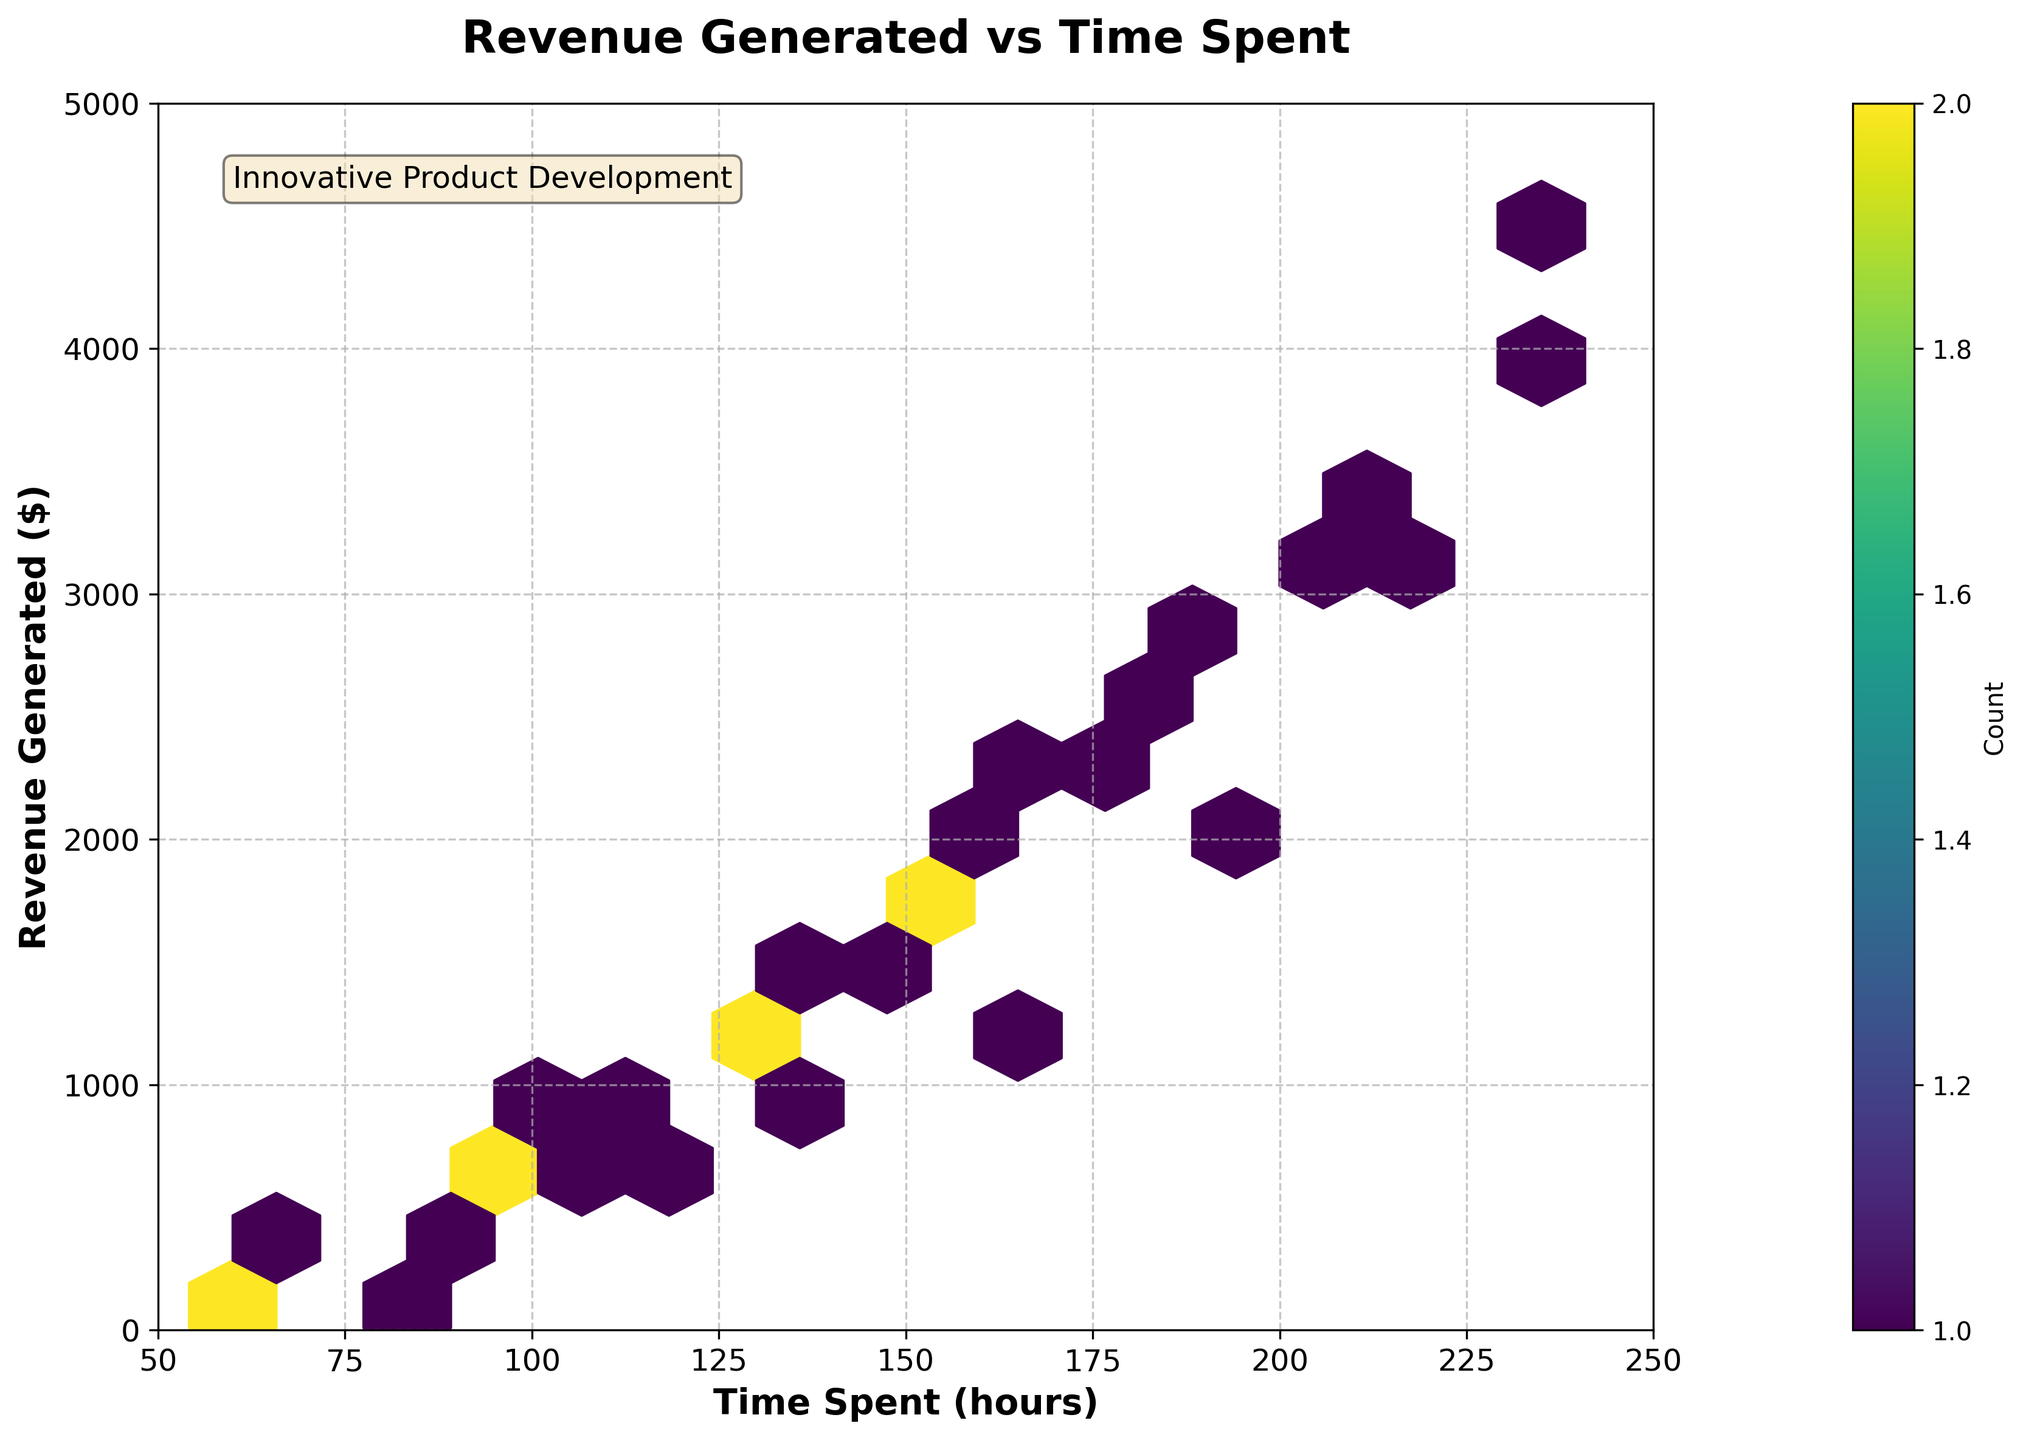What is the title of the figure? The title of the figure is usually written at the top center of the figure. In this case, it is 'Revenue Generated vs Time Spent'.
Answer: 'Revenue Generated vs Time Spent' What ranges are covered by the x-axis and y-axis? The x-axis range is from 50 to 250, and the y-axis range is from 0 to 5000. These ranges are indicated by the limits set on the x and y axes respectively.
Answer: x-axis: 50-250, y-axis: 0-5000 How many data points are there with 'Time Spent (hours)' approximately at 100 and 'Revenue Generated ($)' around 800? The hexbin plot shows hexagons colored based on the count of data points within that bin. By looking at the color intensity of the hexagon around the coordinates (100, 800), we can determine the count. According to the color bar, this specific hexagon corresponds to one data point.
Answer: 1 Which hexagon has the highest count and what does it indicate? The hexagon with the highest count is the one with the most intense color. According to the color bar, the darkest color indicates the highest count, which is 2 in this case. This hexagon is located near (135, 1300).
Answer: The hexagon near (135, 1300) with a count of 2 What is the Revenue Generated when the Time Spent is maximum? The maximum 'Time Spent (hours)' value on the x-axis is 235, and the corresponding 'Revenue Generated ($)' for this value is 4500 as indicated by the data points on the plot.
Answer: 4500 Are there any outliers, i.e., data points significantly distant from others? Outliers in a hexbin plot can be identified as isolated hexagons far from the majority cluster. In the given figure, there are no extreme outliers, as all hexagons appear relatively close to the main diagonal trend.
Answer: No significant outliers How is the overall trend between 'Time Spent (hours)' and 'Revenue Generated ($)' depicted in the plot? The hexbin plot shows a general upward trend, indicating that as 'Time Spent (hours)' increases, 'Revenue Generated ($)' also tends to increase. This is observed by the concentration of hexagons moving upwards as they move to the right.
Answer: Upward trend What is the Revenue Generated when Time Spent is 150 hours? By checking the hexagon corresponding to 150 hours on the x-axis, we see from the plot that it maps to about 1800 dollars on the y-axis.
Answer: 1800 How does the Revenue Generated at 80 hours compare to that at 220 hours? At 80 hours, the Revenue Generated is around 200 dollars, and at 220 hours, the Revenue Generated is around 3000 dollars. A comparison shows that the latter is substantially higher.
Answer: 220 hours generates more revenue than 80 hours What does the color bar indicate about the density of the data points? The color bar on the right of the plot indicates the count of data points within each hexagon, with darker colors representing higher counts. This helps understand the density distribution of data within the plot.
Answer: Darker colors represent higher density 